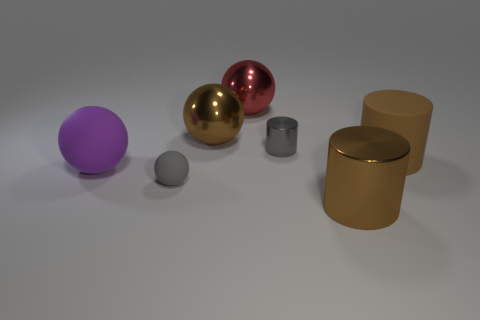Subtract 1 balls. How many balls are left? 3 Subtract all large brown balls. How many balls are left? 3 Add 3 big gray shiny balls. How many objects exist? 10 Subtract all red balls. How many balls are left? 3 Subtract all green spheres. Subtract all red cylinders. How many spheres are left? 4 Subtract all balls. How many objects are left? 3 Subtract all tiny gray spheres. Subtract all large cylinders. How many objects are left? 4 Add 3 big cylinders. How many big cylinders are left? 5 Add 6 small gray cylinders. How many small gray cylinders exist? 7 Subtract 0 green spheres. How many objects are left? 7 